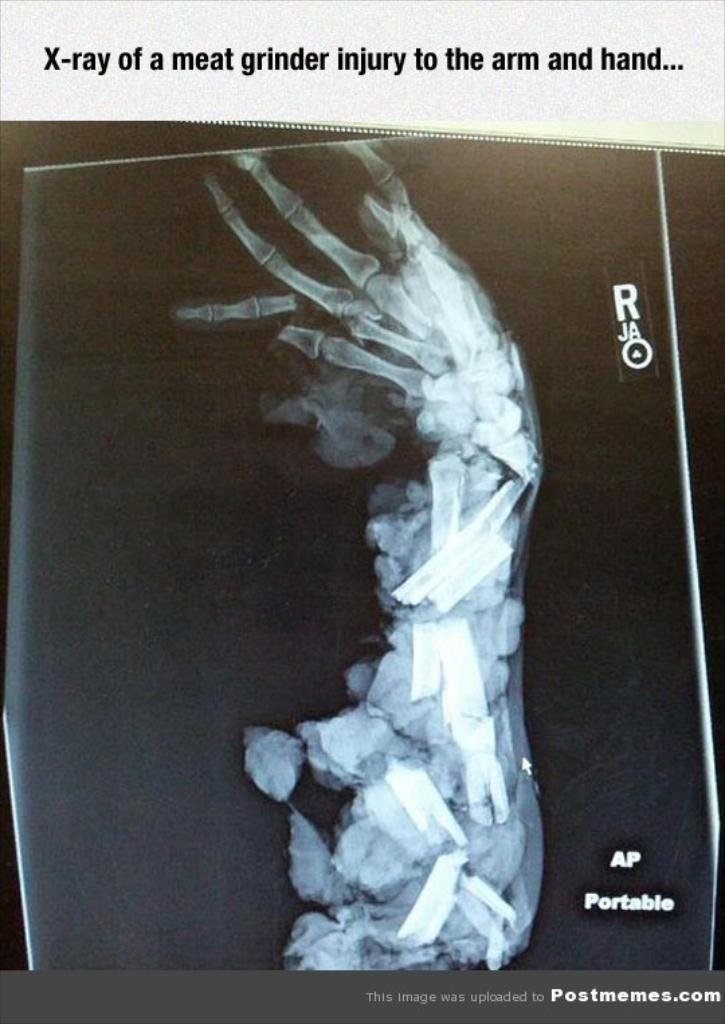What type of image is being described? The image is a poster. What is the main subject of the poster? There is an x-ray in the image. Are there any words or letters on the poster? Yes, there is text in the image. What type of ornament is hanging from the x-ray in the image? There is no ornament present in the image; it only features an x-ray and text. 